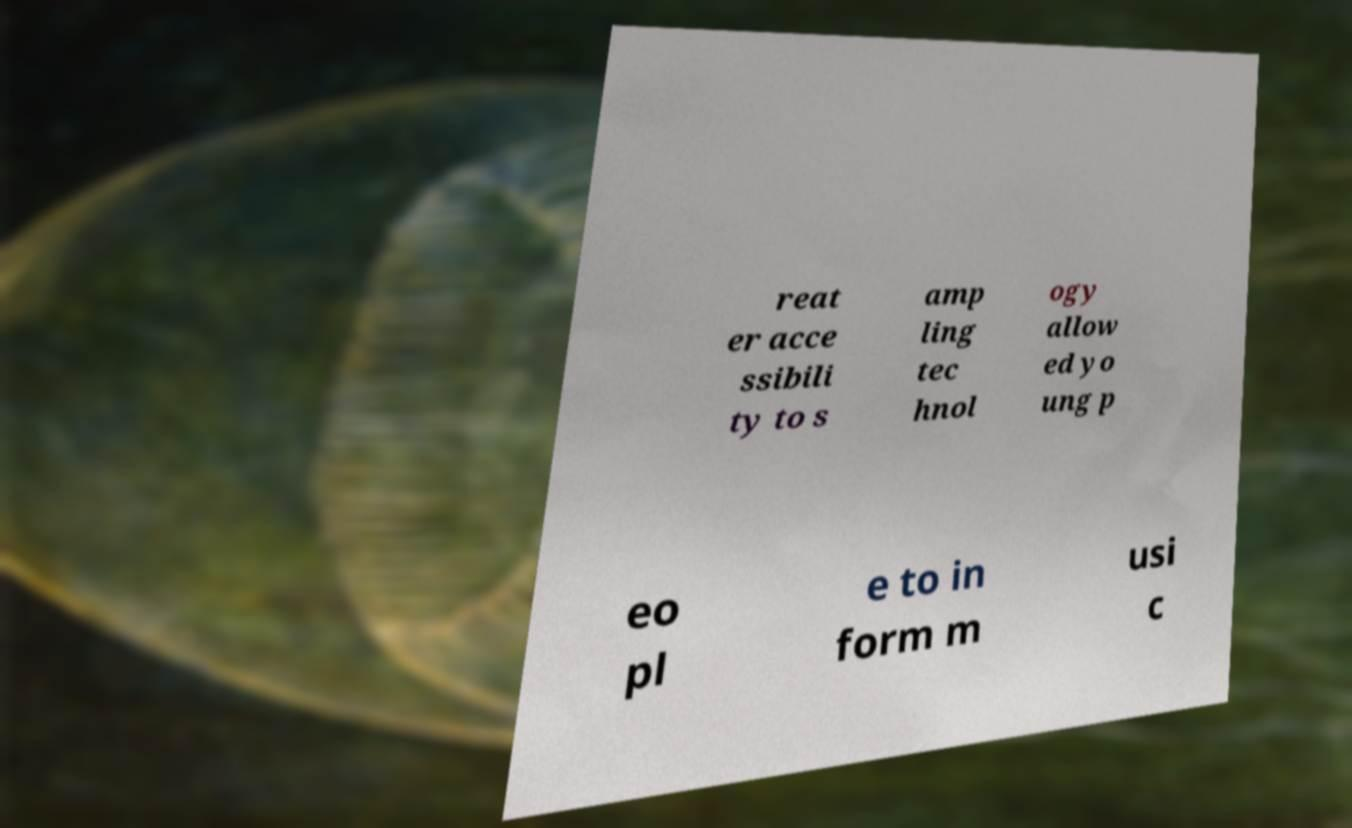Could you assist in decoding the text presented in this image and type it out clearly? reat er acce ssibili ty to s amp ling tec hnol ogy allow ed yo ung p eo pl e to in form m usi c 